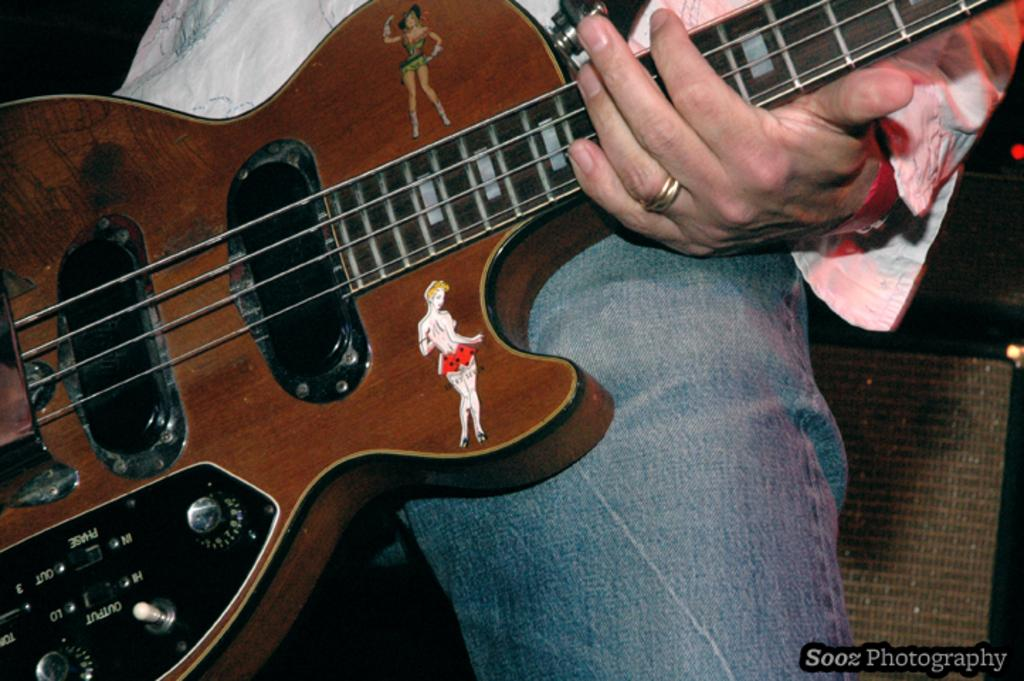What is the main subject of the image? There is a person in the image. What is the person wearing? The person is wearing a white shirt and denim jeans in blue color. What is the person holding in the image? The person is holding a guitar. Can you describe any additional details about the guitar? There are stickers of a woman on the guitar. What type of jewel can be seen on the person's forehead in the image? There is no jewel visible on the person's forehead in the image. 